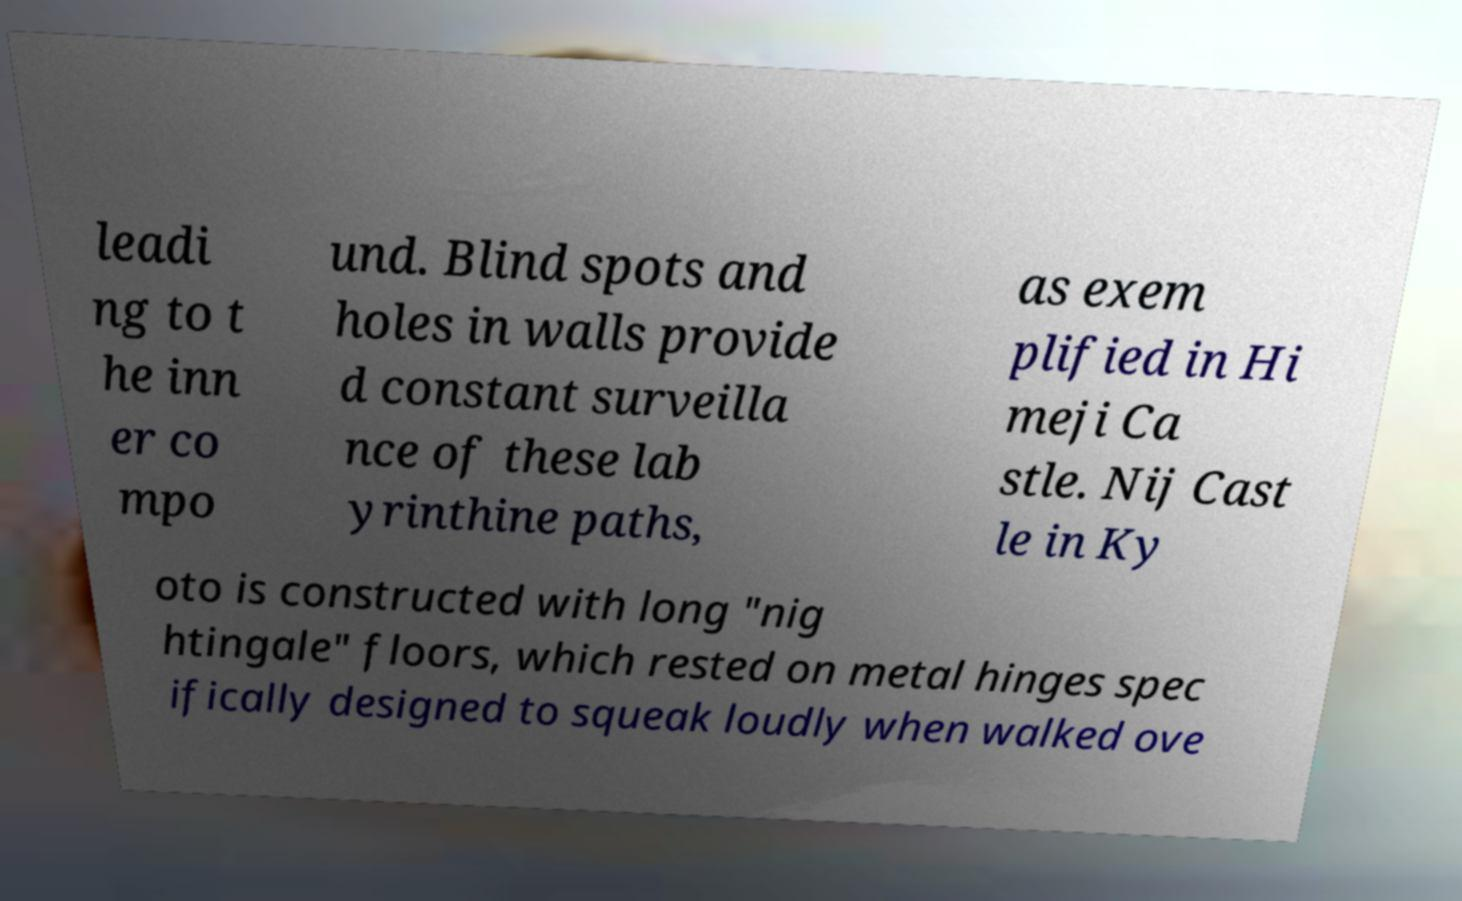Could you assist in decoding the text presented in this image and type it out clearly? leadi ng to t he inn er co mpo und. Blind spots and holes in walls provide d constant surveilla nce of these lab yrinthine paths, as exem plified in Hi meji Ca stle. Nij Cast le in Ky oto is constructed with long "nig htingale" floors, which rested on metal hinges spec ifically designed to squeak loudly when walked ove 